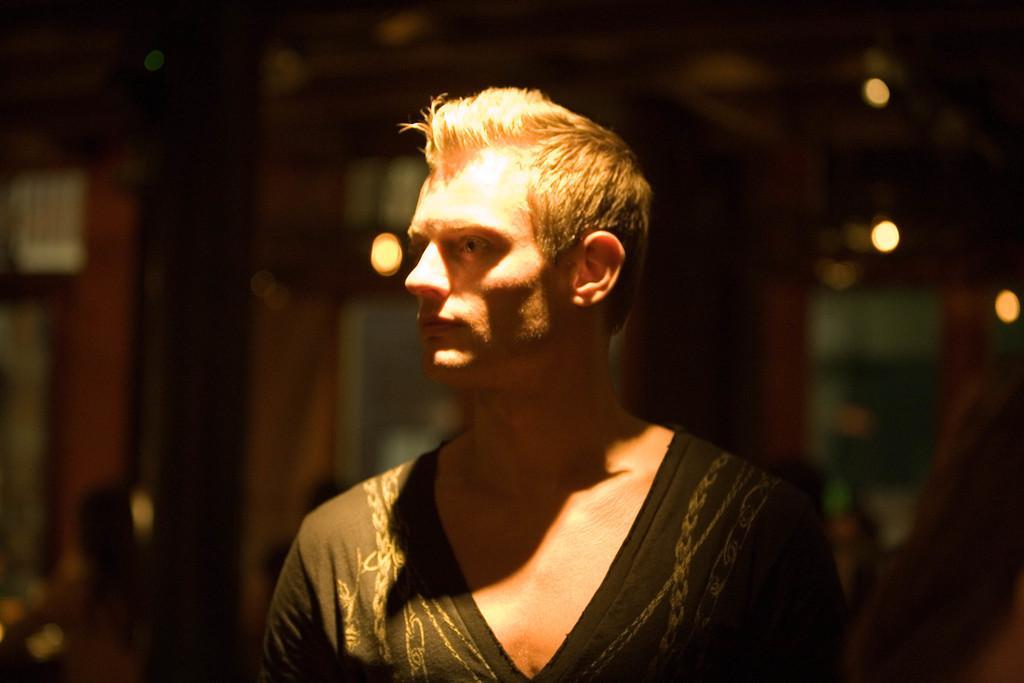How would you summarize this image in a sentence or two? In the middle of the image there is a man with black dress and there is a light on him. Behind him there is a blur background with lights. 